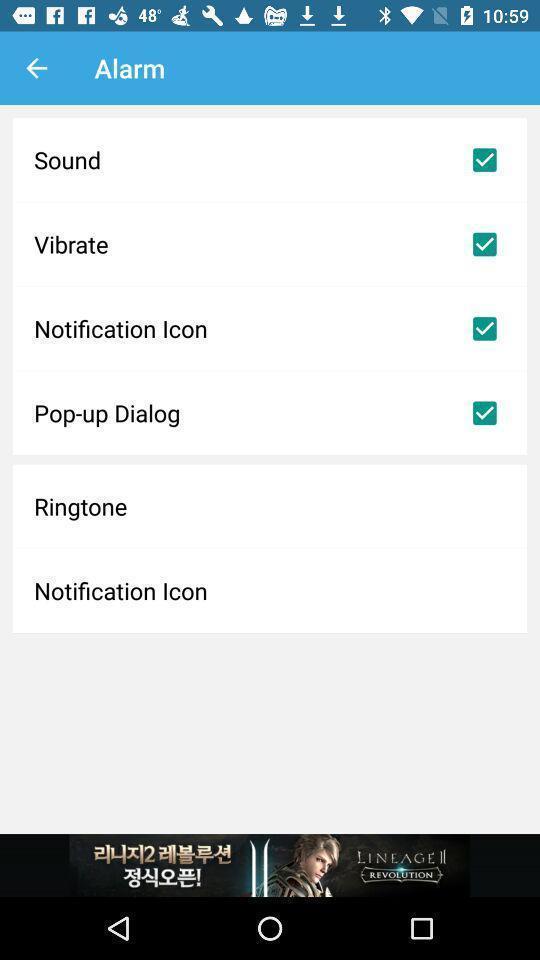Explain what's happening in this screen capture. Page displaying settings option under alarm. 